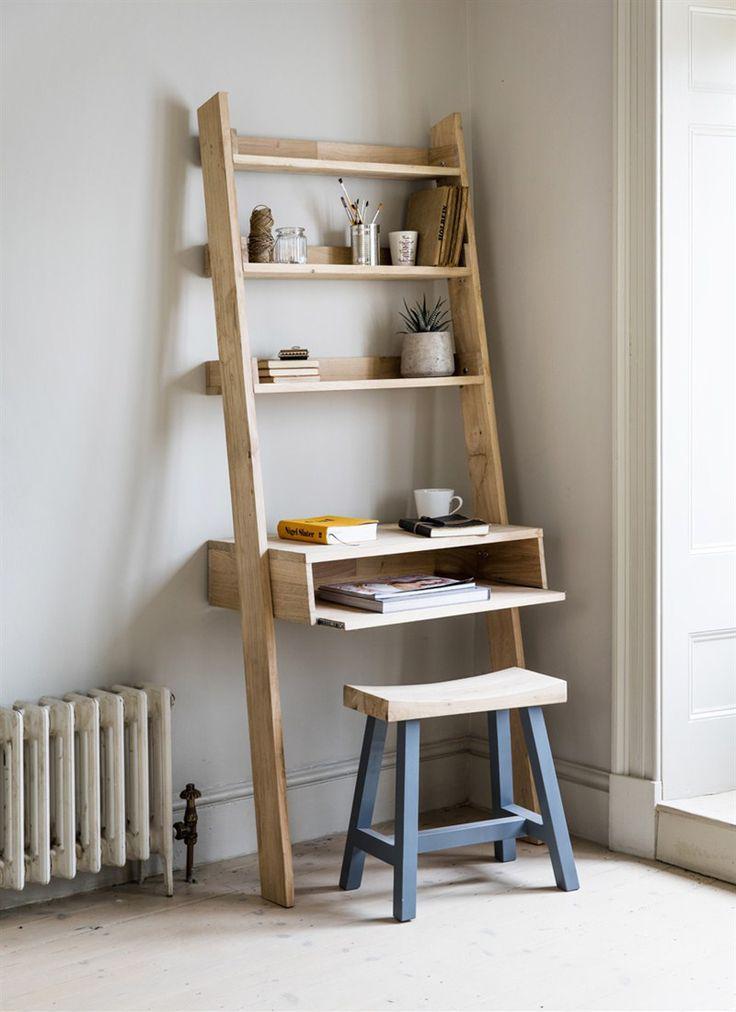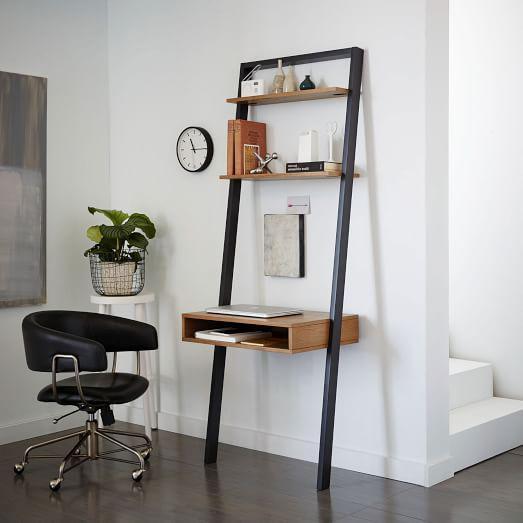The first image is the image on the left, the second image is the image on the right. Examine the images to the left and right. Is the description "The bookshelf on the right is burgundy in color and has a white laptop at its center, and the bookshelf on the left juts from the wall at an angle." accurate? Answer yes or no. No. The first image is the image on the left, the second image is the image on the right. For the images shown, is this caption "One wall unit is cherry brown." true? Answer yes or no. No. 